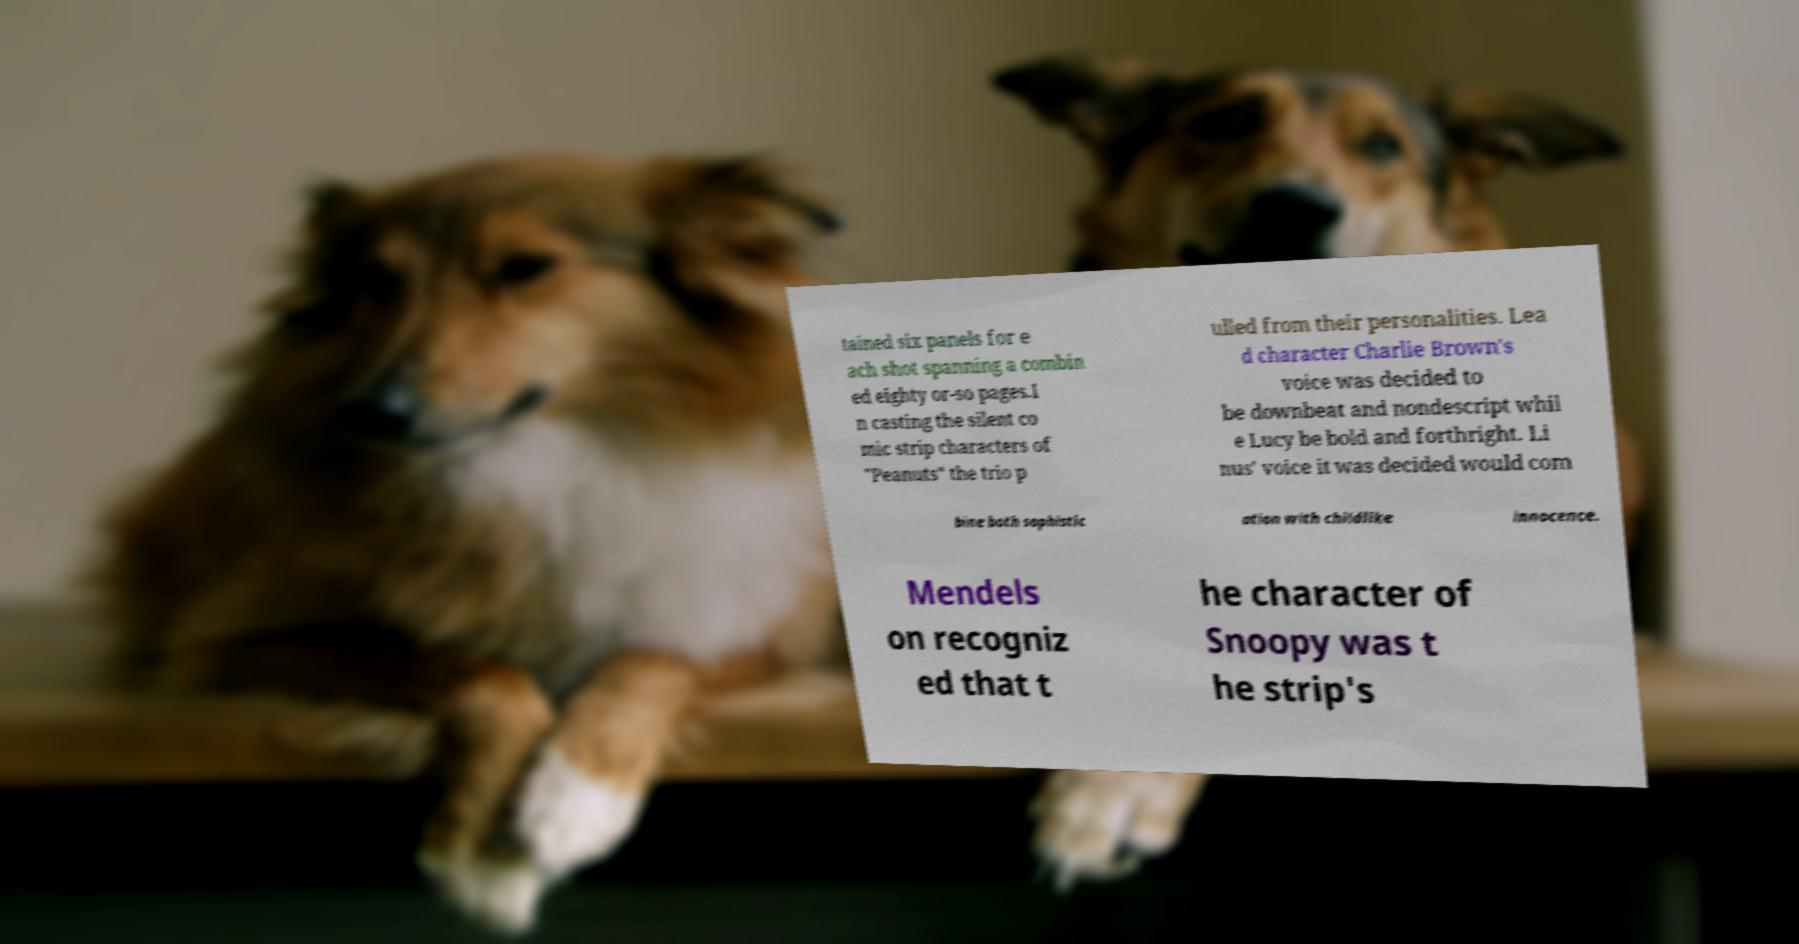What messages or text are displayed in this image? I need them in a readable, typed format. tained six panels for e ach shot spanning a combin ed eighty or-so pages.I n casting the silent co mic strip characters of "Peanuts" the trio p ulled from their personalities. Lea d character Charlie Brown's voice was decided to be downbeat and nondescript whil e Lucy be bold and forthright. Li nus' voice it was decided would com bine both sophistic ation with childlike innocence. Mendels on recogniz ed that t he character of Snoopy was t he strip's 